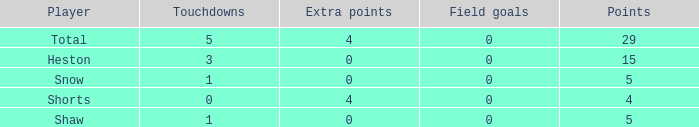What is the sum of all the touchdowns when the player had more than 0 extra points and less than 0 field goals? None. 